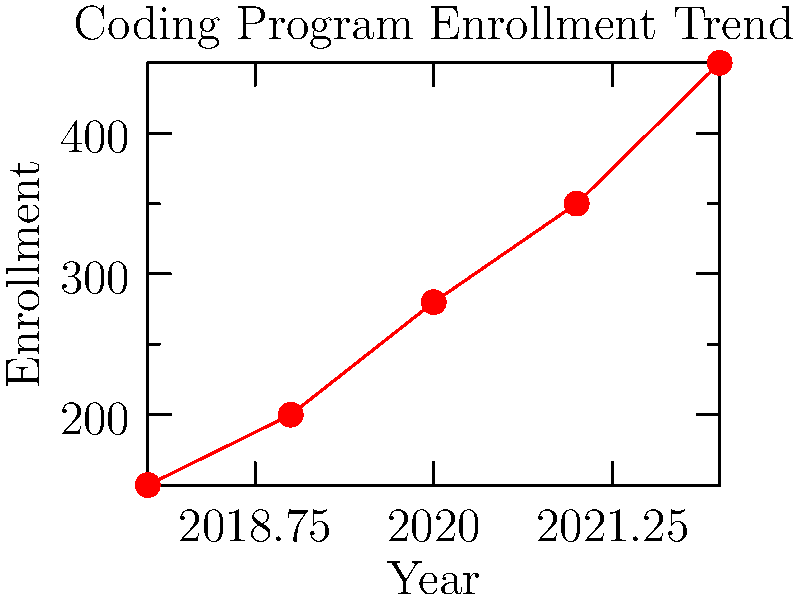Based on the line graph showing the trend of coding program enrollment over the past 5 years, what was the approximate percentage increase in enrollment from 2018 to 2022? To calculate the percentage increase in enrollment from 2018 to 2022:

1. Identify the enrollment numbers:
   2018 enrollment: 150
   2022 enrollment: 450

2. Calculate the difference:
   $450 - 150 = 300$

3. Divide the difference by the initial value:
   $\frac{300}{150} = 2$

4. Convert to percentage:
   $2 \times 100\% = 200\%$

The enrollment increased by approximately 200% from 2018 to 2022.
Answer: 200% 